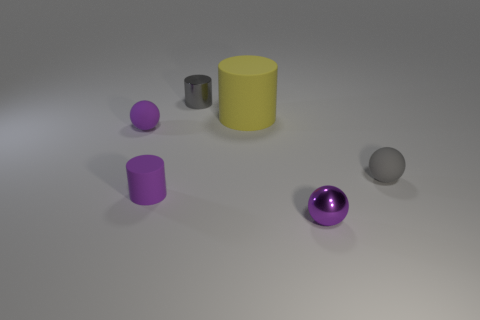Add 2 yellow matte objects. How many objects exist? 8 Subtract all big purple balls. Subtract all big yellow rubber cylinders. How many objects are left? 5 Add 3 tiny gray things. How many tiny gray things are left? 5 Add 4 tiny purple metal objects. How many tiny purple metal objects exist? 5 Subtract 0 green cylinders. How many objects are left? 6 